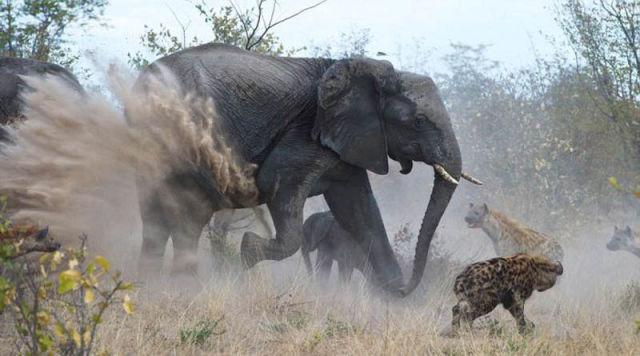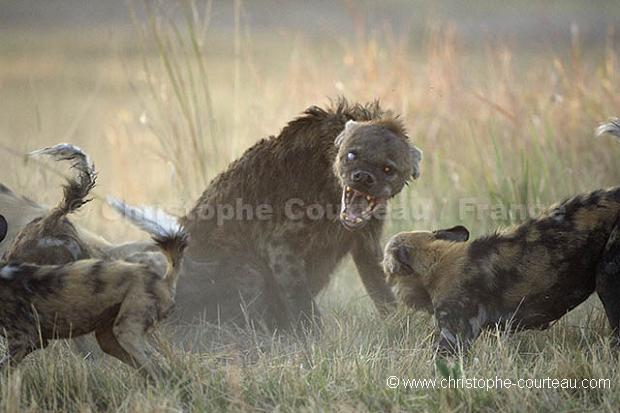The first image is the image on the left, the second image is the image on the right. Assess this claim about the two images: "There is an elephant among hyenas in one of the images.". Correct or not? Answer yes or no. Yes. The first image is the image on the left, the second image is the image on the right. Assess this claim about the two images: "An elephant with tusks is running near a hyena.". Correct or not? Answer yes or no. Yes. 